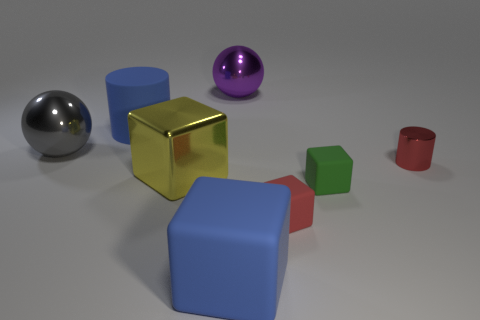Subtract all metal cubes. How many cubes are left? 3 Add 1 red cubes. How many objects exist? 9 Subtract all yellow cubes. How many cubes are left? 3 Subtract 0 cyan balls. How many objects are left? 8 Subtract all balls. How many objects are left? 6 Subtract 2 cubes. How many cubes are left? 2 Subtract all brown cylinders. Subtract all brown cubes. How many cylinders are left? 2 Subtract all blue balls. How many red cylinders are left? 1 Subtract all purple metallic spheres. Subtract all big rubber cylinders. How many objects are left? 6 Add 7 tiny red matte objects. How many tiny red matte objects are left? 8 